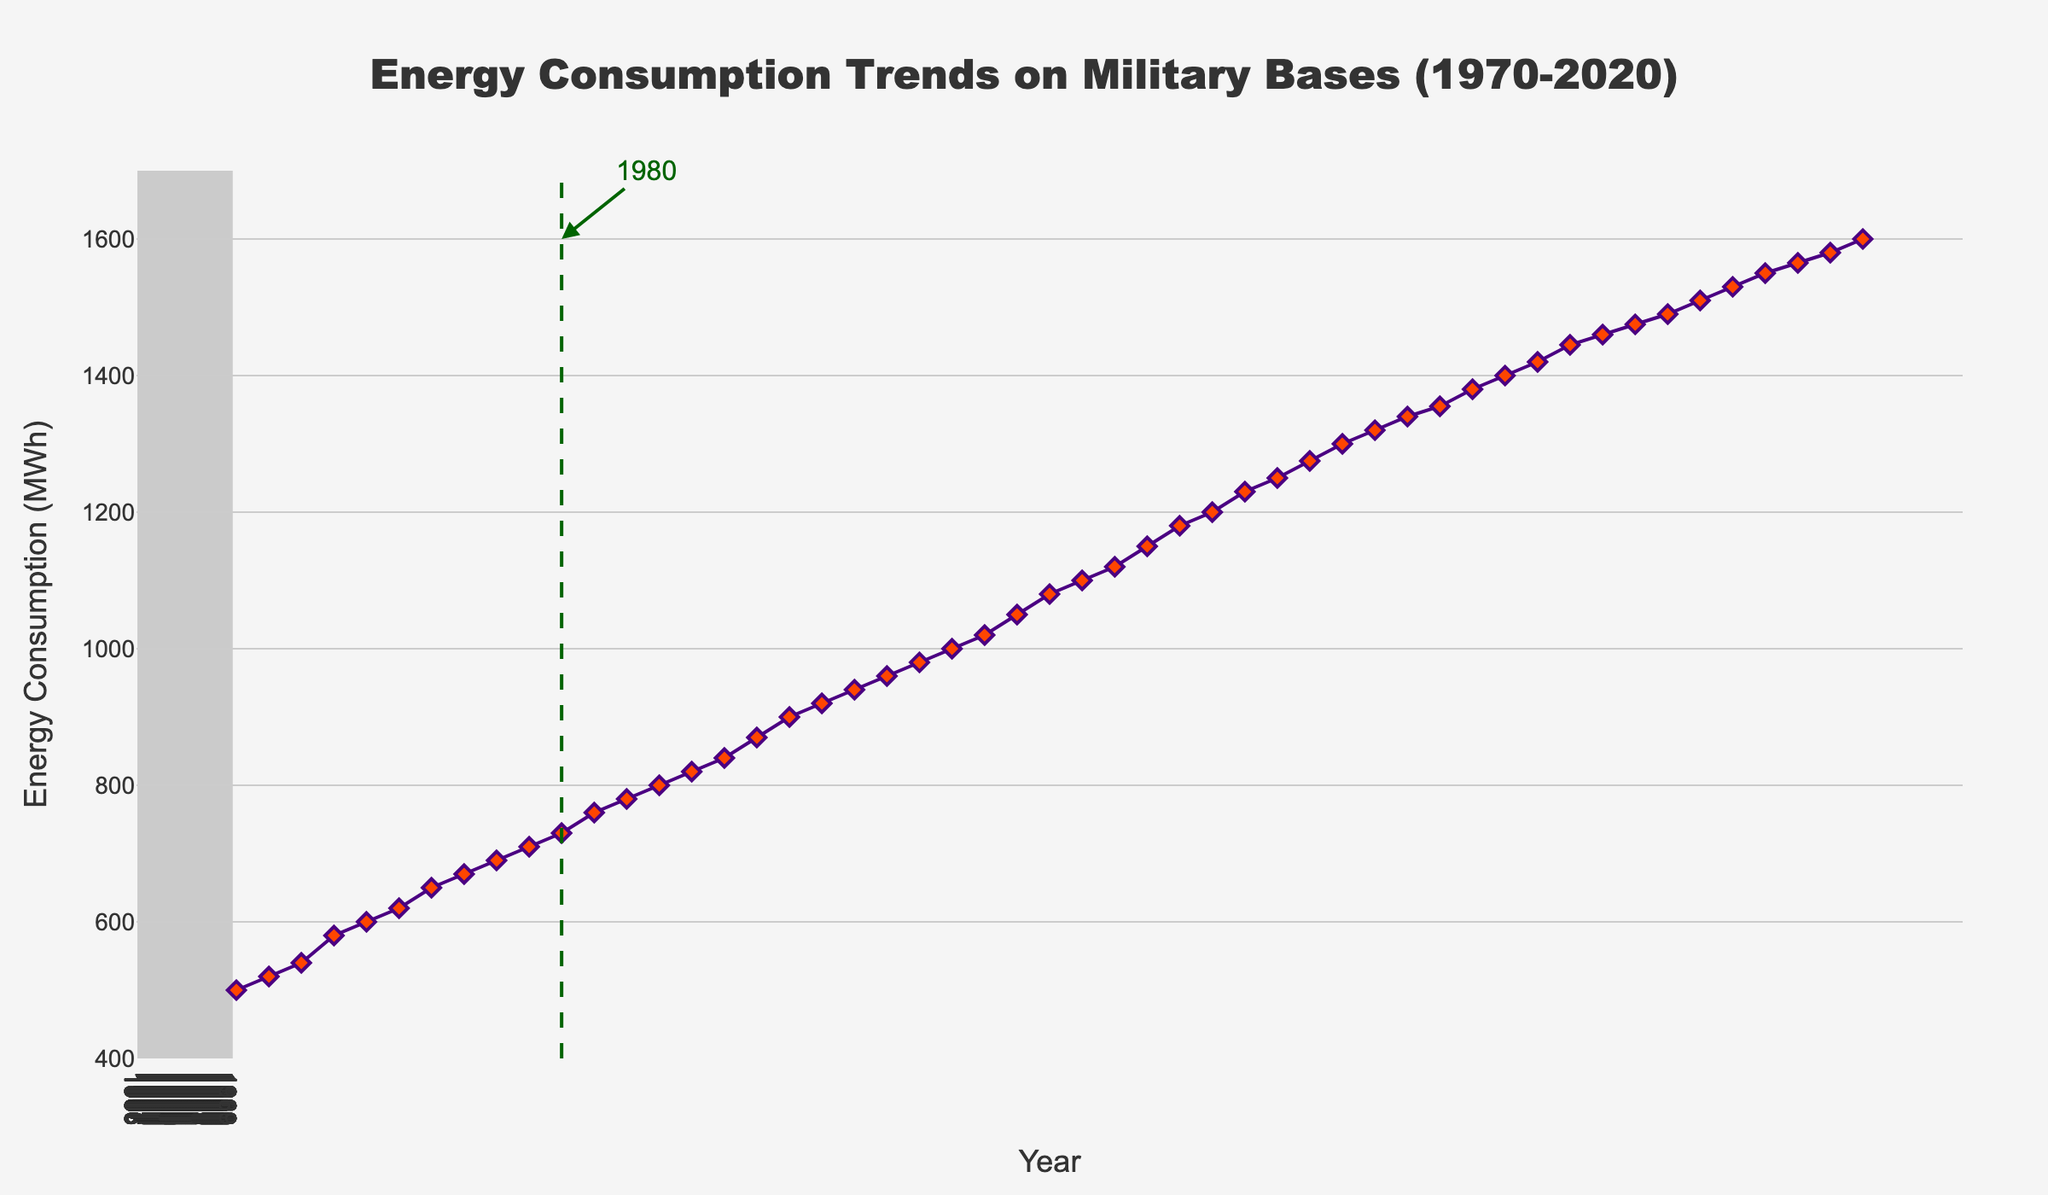What is the title of the plot? The title is at the top center of the plot, describing the overall content of the figure.
Answer: Energy Consumption Trends on Military Bases (1970-2020) What is the range of the energy consumption values shown in the plot? Inspecting the y-axis, the energy consumption values range from a minimum of 500 MWh in 1970 to a maximum of 1600 MWh in 2020.
Answer: 500 MWh to 1600 MWh Which year is marked with a vertical line, and what does it signify? The vertical line is placed at the year 1980, marked on the x-axis, used to signify a noticeable distinction or event.
Answer: 1980 How many distinct years are represented in this time series plot? Observing the x-axis, the data points represent years from 1970 to 2020, inclusive. Counting these gives us 51 distinct years.
Answer: 51 What is the approximate energy consumption for the year 1990? Locating the year 1990 on the x-axis and finding the corresponding data point on the y-axis gives approximately 960 MWh.
Answer: 960 MWh What is the increase in energy consumption from 1970 to 1980? The y-axis values show energy consumption at 500 MWh in 1970 and 730 MWh in 1980. The increase is calculated as 730 - 500 = 230 MWh.
Answer: 230 MWh How did energy consumption change from 2000 to 2020? Energy consumption in 2000 is 1200 MWh, and in 2020 it is 1600 MWh. The change can be found by subtracting these values: 1600 - 1200 = 400 MWh.
Answer: 400 MWh What general trend do you observe in the energy consumption from 1970 to 2020? Observing the direction and slope of the plot line, energy consumption shows a continuous increasing trend over time from 1970 to 2020.
Answer: Increasing What is the average energy consumption for the years 2000 to 2010? The y-axis values for 2000 to 2010 are 1200, 1230, 1250, 1275, 1300, 1320, 1340, 1355, 1380, 1400, and 1420. Summing these values and dividing by 11 gives (1200 + 1230 + 1250 + 1275 + 1300 + 1320 + 1340 + 1355 + 1380 + 1400 + 1420) / 11 = 1315 MWh.
Answer: 1315 MWh Which decade saw the highest relative increase in energy consumption? Calculate the difference in energy consumption at the start and end of each decade and identify the largest increase. The 1980s decade had an increase from 730 MWh to 960 MWh, which is 960 - 730 = 230 MWh. Comparing with the other decades, this is the largest increase.
Answer: 1980s 